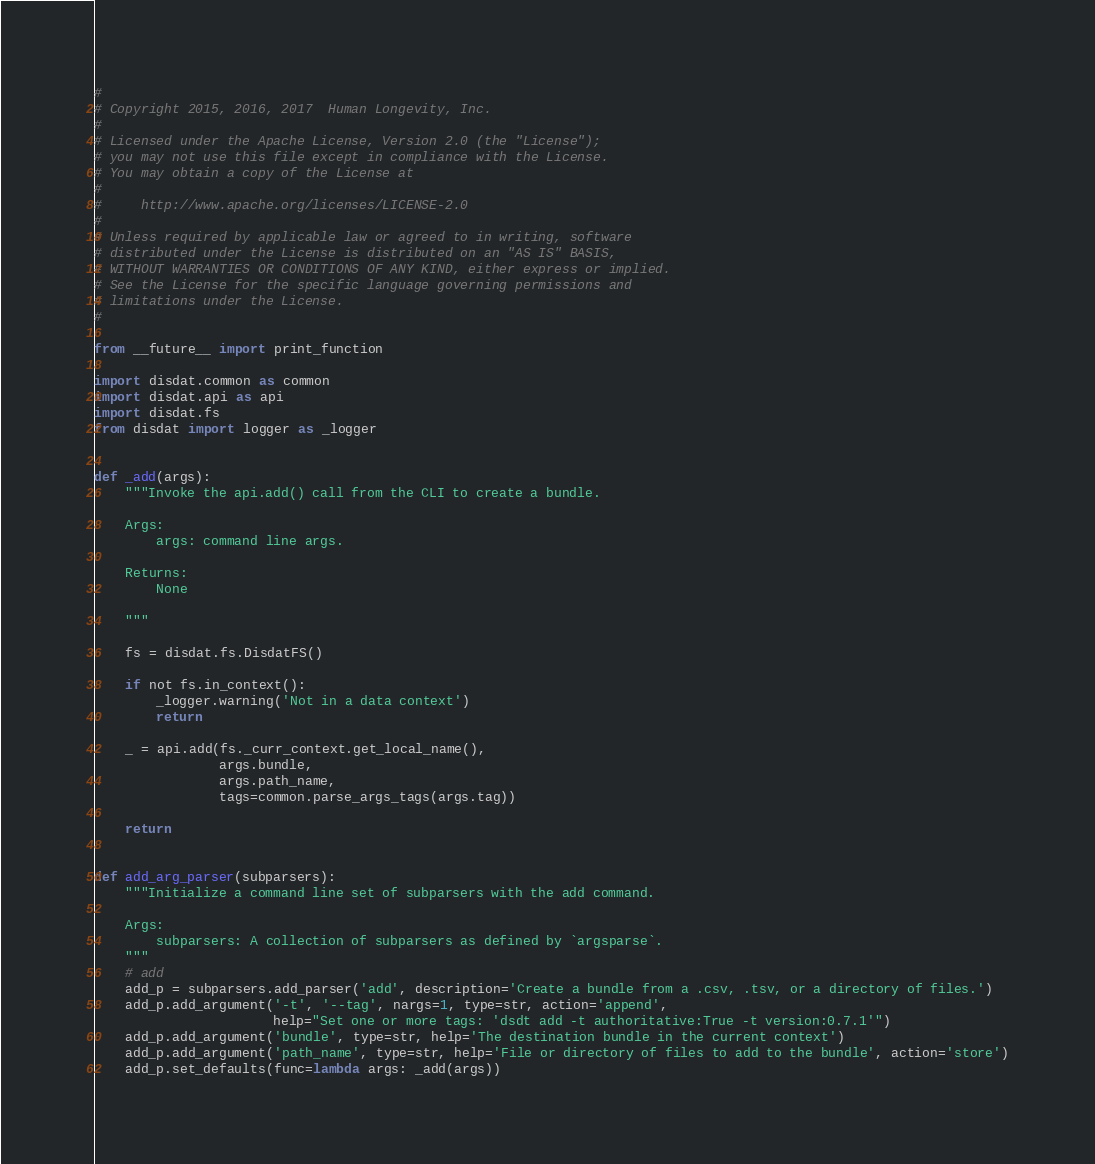Convert code to text. <code><loc_0><loc_0><loc_500><loc_500><_Python_>#
# Copyright 2015, 2016, 2017  Human Longevity, Inc.
#
# Licensed under the Apache License, Version 2.0 (the "License");
# you may not use this file except in compliance with the License.
# You may obtain a copy of the License at
#
#     http://www.apache.org/licenses/LICENSE-2.0
#
# Unless required by applicable law or agreed to in writing, software
# distributed under the License is distributed on an "AS IS" BASIS,
# WITHOUT WARRANTIES OR CONDITIONS OF ANY KIND, either express or implied.
# See the License for the specific language governing permissions and
# limitations under the License.
#

from __future__ import print_function

import disdat.common as common
import disdat.api as api
import disdat.fs
from disdat import logger as _logger


def _add(args):
    """Invoke the api.add() call from the CLI to create a bundle.

    Args:
        args: command line args.

    Returns:
        None

    """

    fs = disdat.fs.DisdatFS()

    if not fs.in_context():
        _logger.warning('Not in a data context')
        return

    _ = api.add(fs._curr_context.get_local_name(),
                args.bundle,
                args.path_name,
                tags=common.parse_args_tags(args.tag))

    return


def add_arg_parser(subparsers):
    """Initialize a command line set of subparsers with the add command.

    Args:
        subparsers: A collection of subparsers as defined by `argsparse`.
    """
    # add
    add_p = subparsers.add_parser('add', description='Create a bundle from a .csv, .tsv, or a directory of files.')
    add_p.add_argument('-t', '--tag', nargs=1, type=str, action='append',
                       help="Set one or more tags: 'dsdt add -t authoritative:True -t version:0.7.1'")
    add_p.add_argument('bundle', type=str, help='The destination bundle in the current context')
    add_p.add_argument('path_name', type=str, help='File or directory of files to add to the bundle', action='store')
    add_p.set_defaults(func=lambda args: _add(args))</code> 